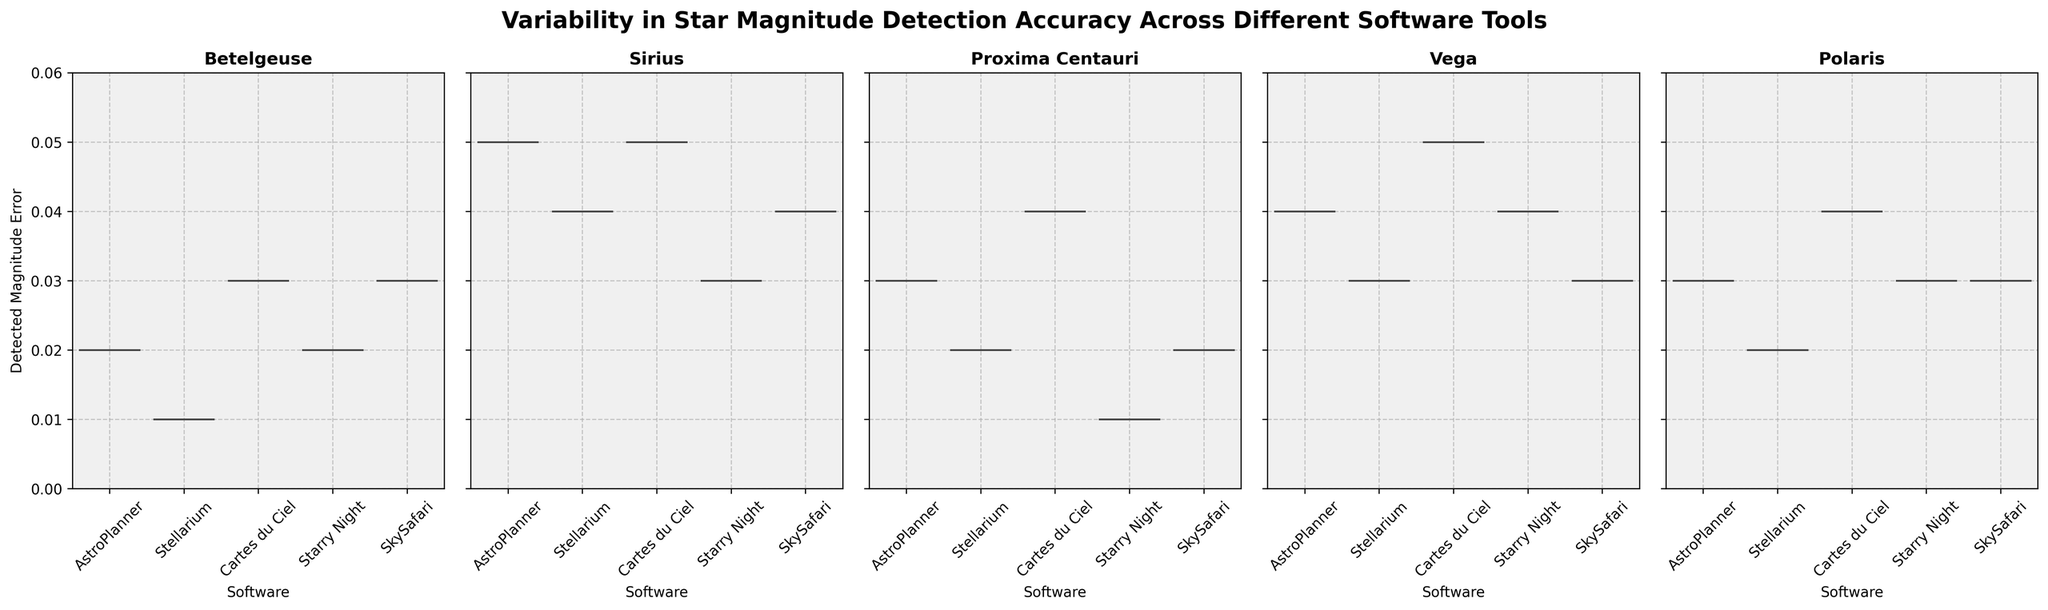What's the title of the figure? The title is usually displayed at the top of the figure, summarizing the main topic.
Answer: Variability in Star Magnitude Detection Accuracy Across Different Software Tools How many software tools are compared in the figure? By counting the number of labels on the x-axis for any of the subplots, we can determine the number of different software tools. There are 5 labels: AstroPlanner, Stellarium, Cartes du Ciel, Starry Night, and SkySafari.
Answer: 5 Which star has the highest detection magnitude error in AstroPlanner? Look at the subplot for each star and find the one that has the highest peak for AstroPlanner. For Betelgeuse, Sirius, Proxima Centauri, Vega, and Polaris, the highest detection magnitude errors are 0.02, 0.05, 0.03, 0.04, 0.03 respectively. The highest of these is 0.05 for Sirius.
Answer: Sirius What's the most consistent software in detecting Betelgeuse's magnitude? We can judge consistency by the spread of the violin plot. A narrow plot indicates lower variability. Here, the Stellarium subplot for Betelgeuse has the narrowest spread.
Answer: Stellarium Which software shows the largest spread in detected magnitude error for Vega? By observing the width and range of the violin plot for each software under the Vega subplot, Cartes du Ciel shows the widest spread, indicating the largest variability.
Answer: Cartes du Ciel In the subplot for Polaris, which software tools have the same median detected magnitude error? By looking at the white dots inside the violin plots (which represent the median), we can compare and see if the medians align. Both AstroPlanner and Starry Night have medians at 0.03.
Answer: AstroPlanner and Starry Night Comparing Betelgeuse and Proxima Centauri, does any software tool have equal median values for both stars? By observing the white dots on the violin plots in both subplots, we see that Starry Night has medians of 0.02 for Betelgeuse and 0.01 for Proxima Centauri, so no software tool has the same median value for both.
Answer: No Which software tool has the highest detected magnitude error for Polaris, and what is the error value? By observing the highest point on the violin plot in the Polaris subplot, Cartes du Ciel has the highest detected magnitude error, which is 0.04.
Answer: Cartes du Ciel; 0.04 